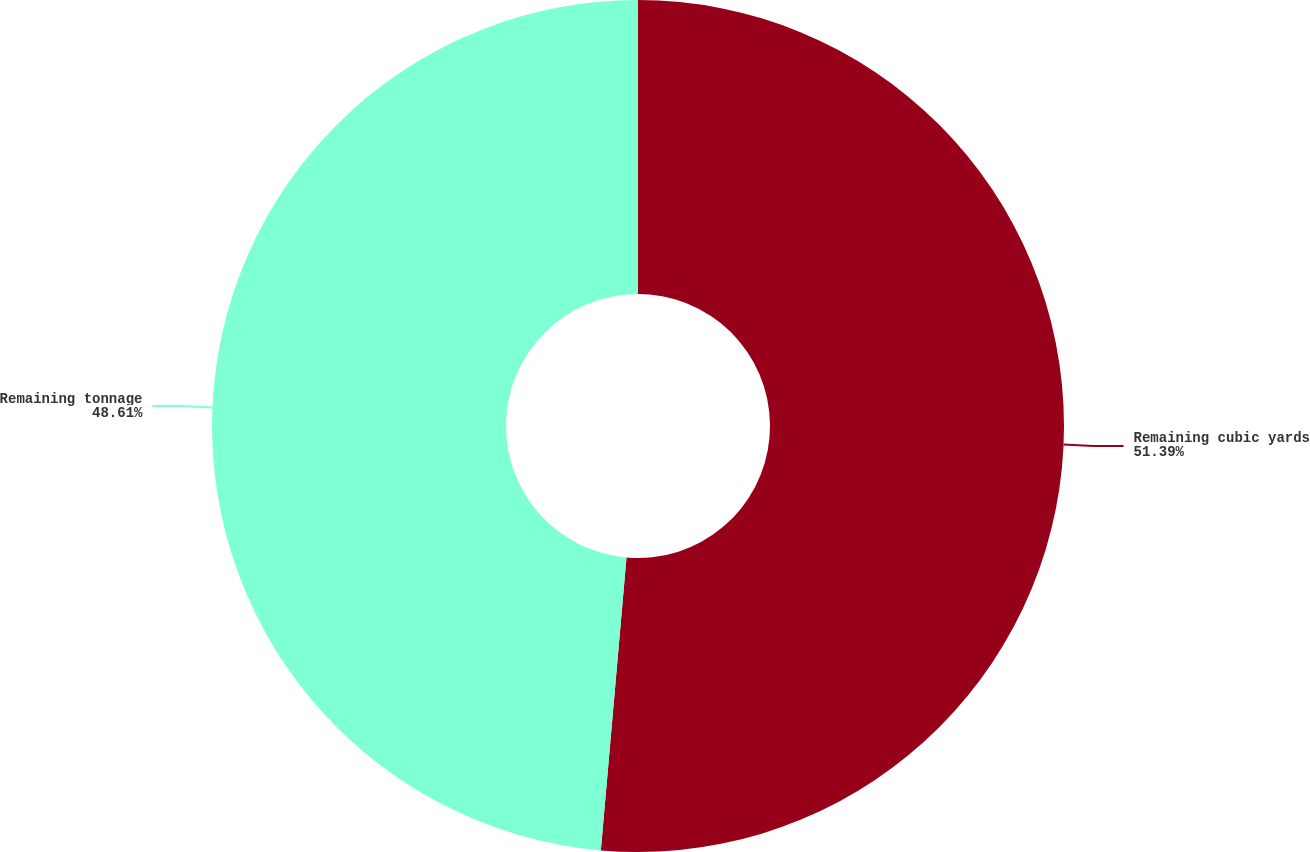<chart> <loc_0><loc_0><loc_500><loc_500><pie_chart><fcel>Remaining cubic yards<fcel>Remaining tonnage<nl><fcel>51.39%<fcel>48.61%<nl></chart> 